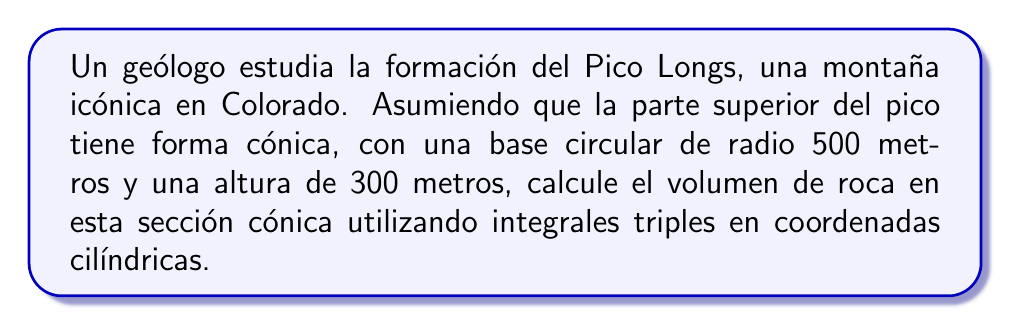Can you answer this question? Para resolver este problema, seguiremos los siguientes pasos:

1) En coordenadas cilíndricas, el volumen se calcula con la integral triple:

   $$V = \iiint r \, dr \, d\theta \, dz$$

2) Definimos los límites de integración:
   - $0 \leq r \leq R - \frac{R}{h}z$ (donde $R$ es el radio de la base y $h$ es la altura)
   - $0 \leq \theta \leq 2\pi$
   - $0 \leq z \leq h$

3) Sustituyendo los valores dados: $R = 500$ m, $h = 300$ m

   $$V = \int_0^{300} \int_0^{2\pi} \int_0^{500-\frac{5}{3}z} r \, dr \, d\theta \, dz$$

4) Resolvemos la integral triple:

   $$V = \int_0^{300} \int_0^{2\pi} \left[\frac{r^2}{2}\right]_0^{500-\frac{5}{3}z} \, d\theta \, dz$$
   
   $$V = \int_0^{300} \int_0^{2\pi} \frac{1}{2}\left(500-\frac{5}{3}z\right)^2 \, d\theta \, dz$$
   
   $$V = \int_0^{300} 2\pi \cdot \frac{1}{2}\left(500-\frac{5}{3}z\right)^2 \, dz$$
   
   $$V = \pi \int_0^{300} \left(250000-\frac{5000}{3}z+\frac{25}{9}z^2\right) \, dz$$

5) Resolvemos la integral:

   $$V = \pi \left[250000z-\frac{2500}{3}z^2+\frac{25}{27}z^3\right]_0^{300}$$

6) Evaluamos los límites:

   $$V = \pi \left(75000000-75000000+750000\right)$$
   
   $$V = 750000\pi$$

7) Convertimos a metros cúbicos:

   $$V = 2356194.49 \text{ m}^3$$
Answer: $2356194.49 \text{ m}^3$ 